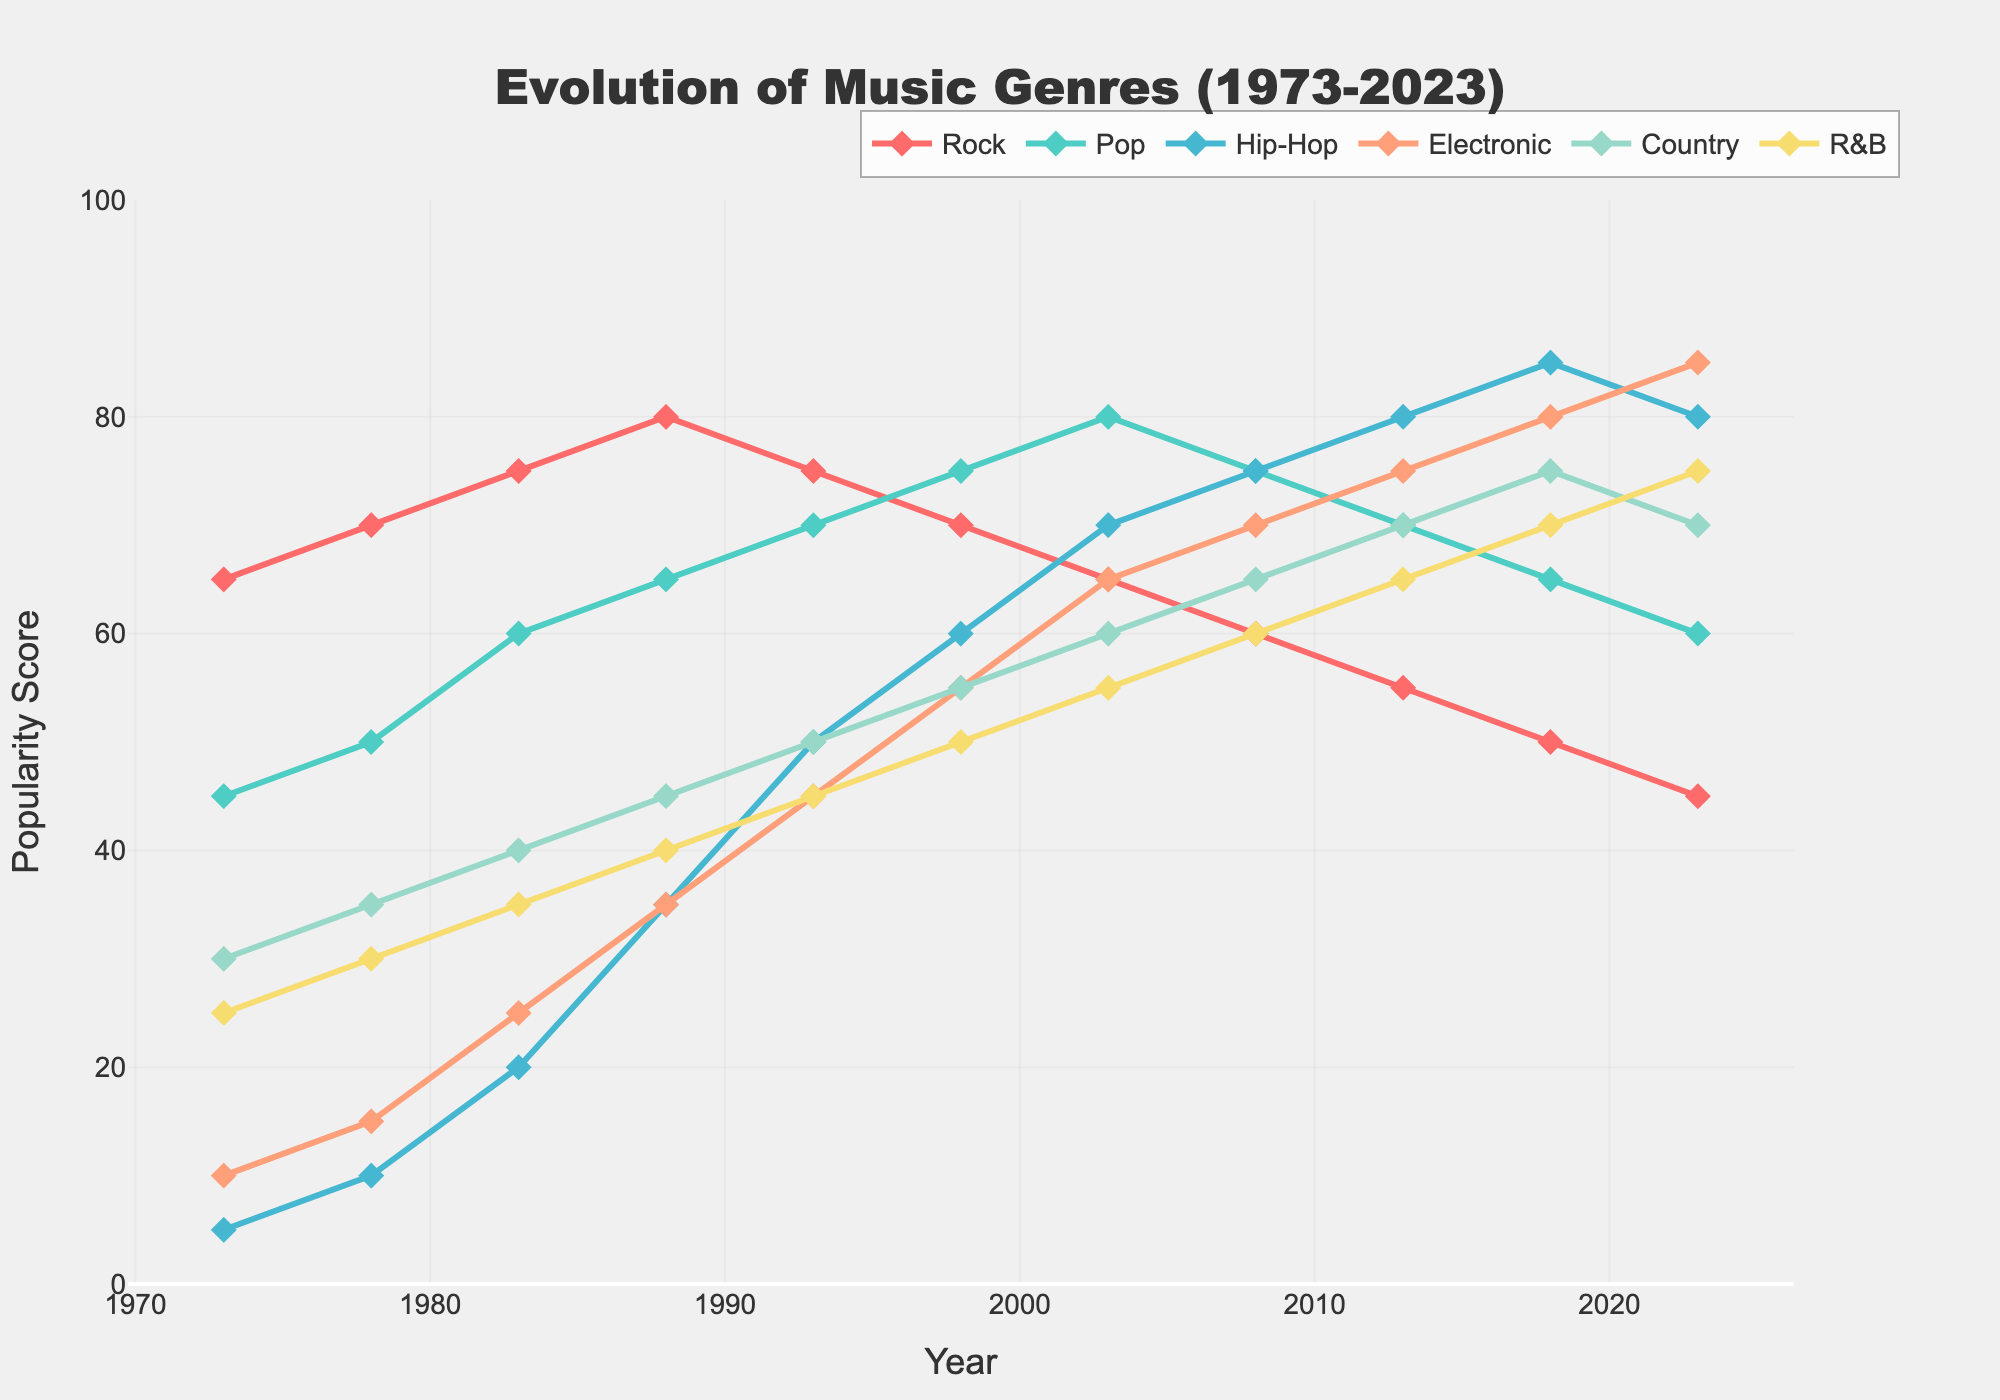What genre was the most popular in 2023? The year 2023 shows the highest point on the line representing a genre's popularity. The line with the highest final value is Electronic at a height of 85.
Answer: Electronic How has the popularity of Rock changed from 1973 to 2023? To determine this, observe the data points for Rock at 1973 and 2023. Rock started at a value of 65 in 1973 and decreased to 45 by 2023. This indicates a decline over the period.
Answer: Decreased In which year did Hip-Hop surpass Rock in popularity? Look at the intersection of the lines representing Hip-Hop and Rock. Hip-Hop's value first exceeds Rock's in 2008 where Hip-Hop is 75 and Rock is 60.
Answer: 2008 Which genre showed the most consistent increase in popularity over the 50 years? To answer this, observe the slope of each line from 1973 to 2023. Electronic shows a consistent upward trend, starting from 10 in 1973 and reaching 85 in 2023 without any declines.
Answer: Electronic Between 1983 and 2003, which genre had the greatest increase in popularity? Examine the difference in popularity values between 1983 and 2003 for each genre. Calculate the change: Rock (+10), Pop (+20), Hip-Hop (+50), Electronic (+40), Country (+20), R&B (+20). Hip-Hop had the greatest increase.
Answer: Hip-Hop What is the average popularity of Pop in the decades shown? Sum the values for Pop over the provided years and divide by the number of years: (45+50+60+65+70+75+80+75+70+65+60)/11 = 705/11. The average popularity of Pop is 64.1.
Answer: 64.1 Is there any genre that decreased constantly from 1993 to 2023? Review the values of each genre from 1993 to 2023. Rock is the only genre that shows a constant decline, from 75 in 1993 to 45 in 2023.
Answer: Rock Which two genres were most popular in 1998? Observe the data points for each genre in 1998. The highest values were Pop at 75 and R&B at 50. Therefore, the most popular genres in 1998 were Pop and R&B.
Answer: Pop and R&B In what year did the popularity of R&B equal that of Hip-Hop? Look for the intersection of the R&B and Hip-Hop lines. The lines cross at 80, which happens in the year 2013.
Answer: 2013 